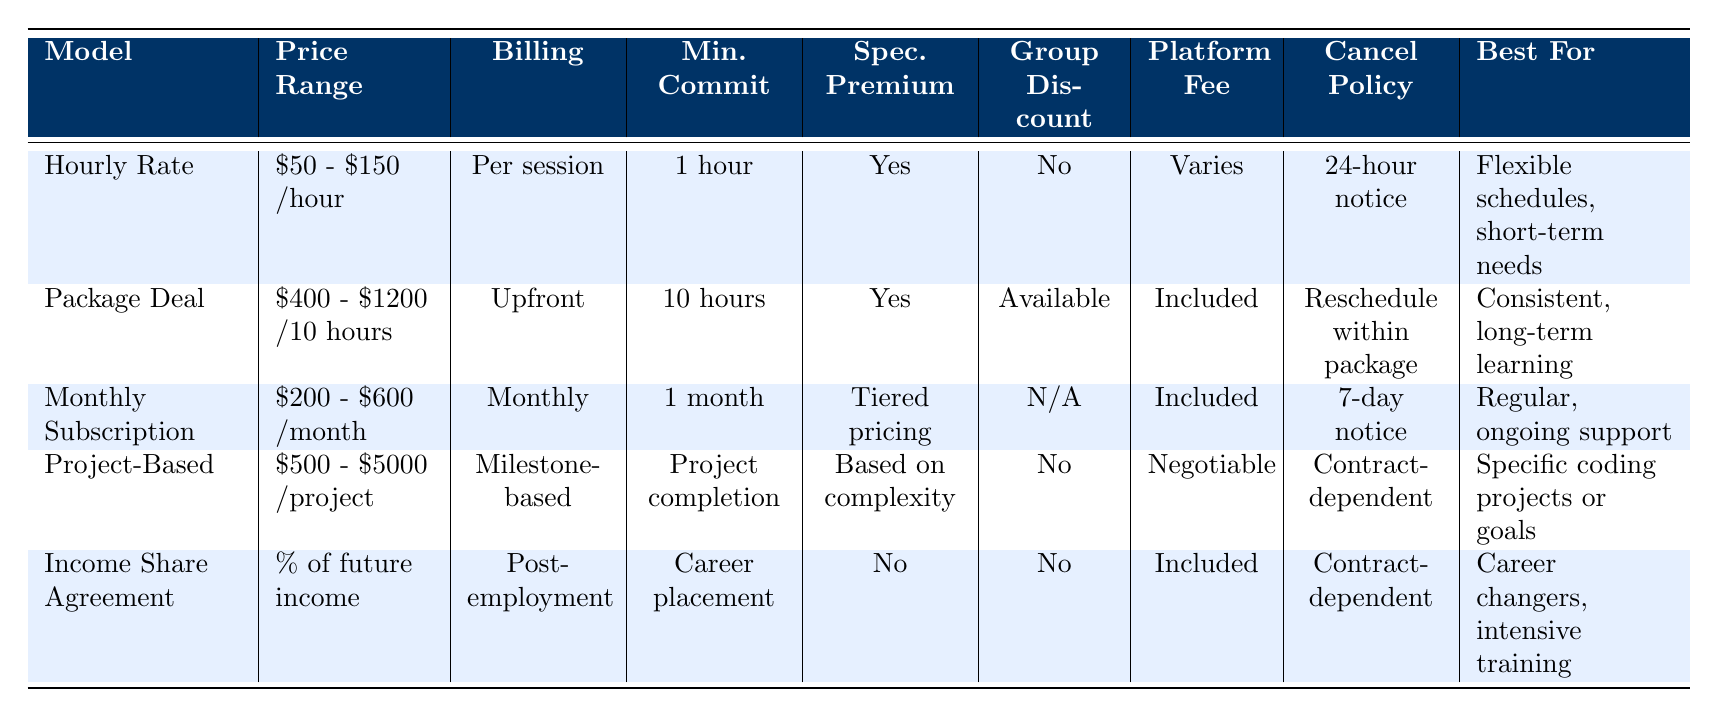What is the price range for the Package Deal model? The table lists the price range for the Package Deal model as "$400 - $1200 for 10 hours".
Answer: $400 - $1200 for 10 hours Is there a group discount available for the Hourly Rate model? The table indicates "No" under the Group Discount column for the Hourly Rate model.
Answer: No What is the maximum price range for Project-Based tutoring? Based on the table, the maximum price range for Project-Based tutoring is "$5000".
Answer: $5000 Which pricing model has a cancellation policy that requires a 24-hour notice? The Hourly Rate model has a cancellation policy requiring a 24-hour notice, as stated in the table.
Answer: Hourly Rate How many models offer a specialization premium? The table shows that the Hourly Rate, Package Deal, and Project-Based models offer a specialization premium; three models in total.
Answer: 3 What is the average price range per hour for Hourly Rate and Package Deal models? The hourly range for Hourly Rate is $50 - $150. For the Package Deal, when calculated per hour for ten hours, it becomes $40 - $120. Taking the average for both models gives us ($50 + $150 + $40 + $120) / 4 = $110.
Answer: $110 Is the Platform Fee included in the Monthly Subscription model? Yes, the Table explicitly states "Included" in the Platform Fee column for the Monthly Subscription model.
Answer: Yes Which model is best for individuals seeking specific coding projects based on the table? The Project-Based model is described as best for "Specific coding projects or goals" in the Best For column.
Answer: Project-Based What is the minimum commitment for the Income Share Agreement model? According to the table, the minimum commitment for the Income Share Agreement model is "Career placement".
Answer: Career placement 